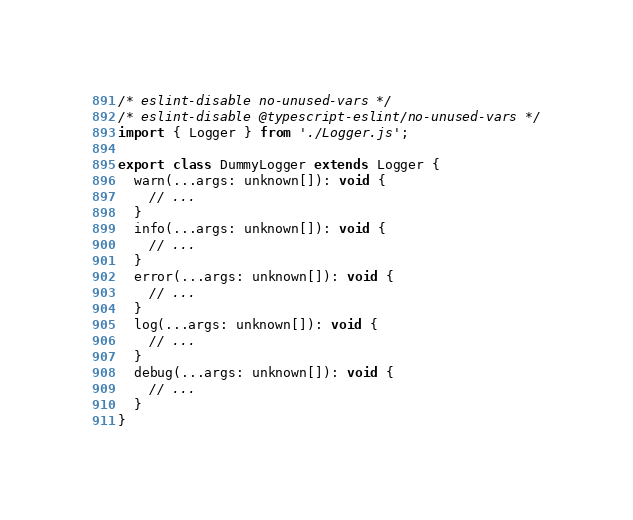<code> <loc_0><loc_0><loc_500><loc_500><_TypeScript_>/* eslint-disable no-unused-vars */
/* eslint-disable @typescript-eslint/no-unused-vars */
import { Logger } from './Logger.js';

export class DummyLogger extends Logger {
  warn(...args: unknown[]): void {
    // ...
  }
  info(...args: unknown[]): void {
    // ...
  }
  error(...args: unknown[]): void {
    // ...
  }
  log(...args: unknown[]): void {
    // ...
  }
  debug(...args: unknown[]): void {
    // ...
  }
}
</code> 